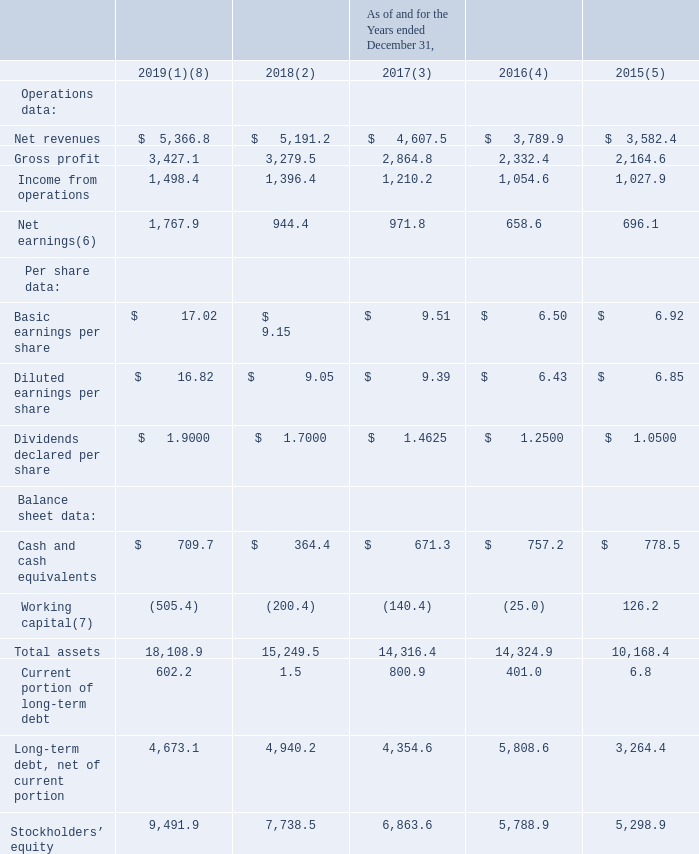ITEM 6 | SELECTED FINANCIAL DATA
You should read the table below in conjunction with “Management’s Discussion and Analysis of Financial Condition and Results of Operations” and our Consolidated Financial Statements and related notes included in this Annual Report (amounts in millions, except per share data).
(1)  Includes results from the acquisitions of Foundry from April 18, 2019, ComputerEase from August 19, 2019, iPipeline from August 22, 2019, and Bellefield from December 18, 2019; and the results from the Imaging businesses through disposal on February 5, 2019 and Gatan through disposal on October 29, 2019.
(2)  Includes results from the acquisitions of Quote Software from January 2, 2018, PlanSwift Software from March 28, 2018, Smartbid from May 8, 2018, PowerPlan, Inc. from June 4, 2018, ConceptShare from June 7, 2018, BillBlast from July 10, 2018 and Avitru from December 31, 2018.
(3)  Includes results from the acquisitions of Phase Technology from June 21, 2017, Handshake Software, Inc. from August 4, 2017, Workbook Software A/S from September 15, 2017 and Onvia, Inc. from November 17, 2017.
(4)  Includes results from the acquisitions of CliniSys Group Ltd. from January 7, 2016, PCI Medical Inc. from March 17, 2016, GeneInsight Inc. from April 1, 2016, iSqFt Holdings Inc. (d/b/a ConstructConnect) from October 31, 2016, UNIConnect LC from November 10, 2016 and Deltek, Inc. from December 28, 2016.
(5)  Includes results from the acquisitions of Strata Decision Technologies LLC from January 21, 2015, SoftWriters Inc. from February 9, 2015, Data Innovations LLC from March 4, 2015, On Center Software LLC from July 20, 2015, RF IDeas Inc. from September 1, 2015, Atlantic Health Partners LLC from September 4, 2015, Aderant Holdings Inc. from October 21, 2015, Atlas Database Software Corp. from October 26, 2015; and the results from the Black Diamond Advanced Technologies through disposal on March 20, 2015 and Abel Pumps through disposal on October 2, 2015.
(6)  The Company recognized an after tax gain of $687.3 in connection with the dispositions of the Imaging businesses and Gatan during 2019. The Tax Cuts and Jobs Act of 2017 (“the Tax Act”) was signed into U.S. law on December 22, 2017, which was prior to the end of the Company’s 2017 reporting period and resulted in a one-time net income tax benefit of $215.4.
(7)  Net working capital equals current assets, excluding cash, less total current liabilities, excluding debt.
(8)  In 2019 working capital includes the impact of the increase in income taxes payable of approximately $200.0 due to the taxes incurred on the gain on sale of Gatan, and the adoption of Accounting Standards Codification (“ASC”) Topic 842, Leases (“ASC 842”) which resulted in an increase to current liabilities of $56.8 as of December 31, 2019. The other balance sheet accounts impacted due to the adoption of ASC 842 are set forth in Note 16 of the Notes to Consolidated Financial Statements included in this Annual Report.
How should we read the table in conjunction with it? “management’s discussion and analysis of financial condition and results of operations” and our consolidated financial statements and related notes included in this annual report. What does the operations data consist of? Net revenues, gross profit, income from operations, net earnings. How much were the total assets during fiscal years 2018 and 2019, respectively?
Answer scale should be: million. 15,249.5, 18,108.9. What are the average net revenues from 2015 to 2019?
Answer scale should be: million. (5,366.8+5,191.2+4,607.5+3,789.9+3,582.4)/5 
Answer: 4507.56. What is the percentage change in cash and cash equivalents in 2018 compared to 2015?
Answer scale should be: percent. (364.4-778.5)/778.5 
Answer: -53.19. What is the cost of goods sold (COGS) in 2017?
Answer scale should be: million. 4,607.5 - 2,864.8 
Answer: 1742.7. 